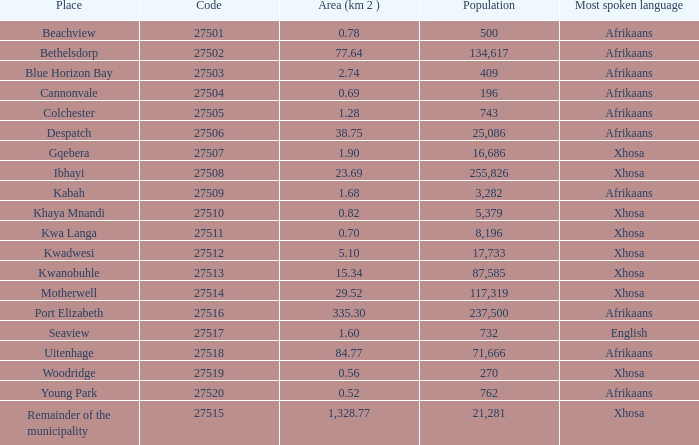What is the place that speaks xhosa, has a population less than 87,585, an area smaller than 1.28 squared kilometers, and a code larger than 27504? Khaya Mnandi, Kwa Langa, Woodridge. 